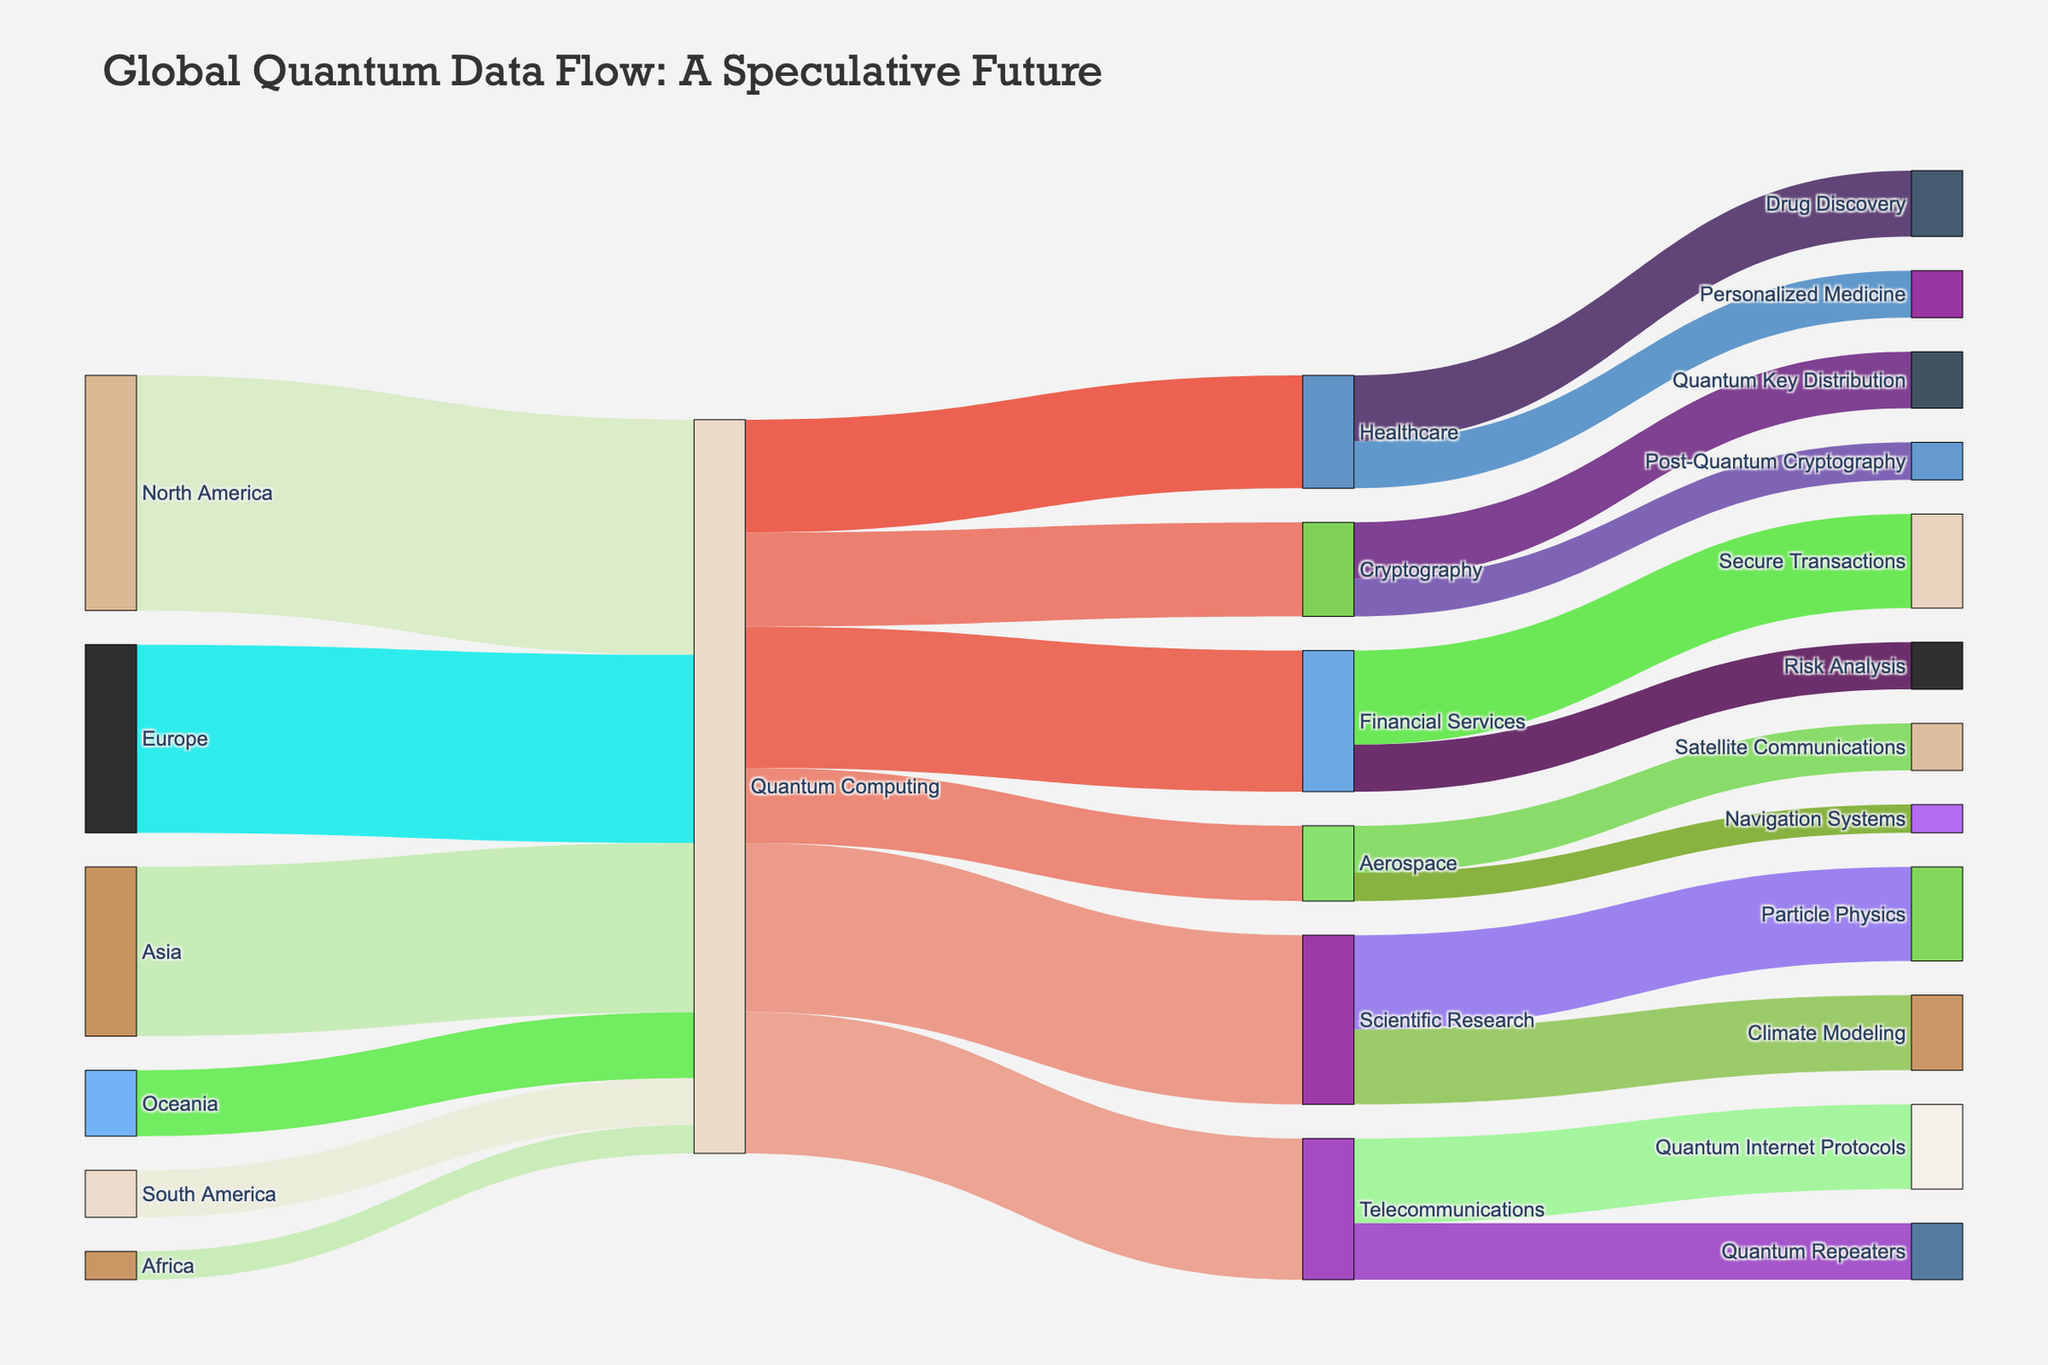What is the title of the figure? The title of the figure is usually displayed at the top in a larger font.
Answer: Global Quantum Data Flow: A Speculative Future Which continent contributes the highest number of quantum bits to Quantum Computing? By analyzing the thickness of the links connected to Quantum Computing from different continents, it's evident that North America has the thickest link, indicating it contributes the most quantum bits.
Answer: North America How many quantum bits are allocated to Financial Services from Quantum Computing? By looking at the link connecting Quantum Computing to Financial Services, you can see the value next to it.
Answer: 150 What is the total number of quantum bits utilized in Healthcare and Financial Services combined? Adding the values for Healthcare (120) and Financial Services (150) from Quantum Computing gives us the total.
Answer: 270 From which three continents does Quantum Computing receive the smallest contribution of quantum bits? Finding the three smallest values in the links connecting the continents to Quantum Computing: Africa (30), South America (50), and Oceania (70).
Answer: Africa, South America, Oceania Which application under Telecommunications receives the most quantum bits? Within the Telecommunications category, the link Quantum Internet Protocols has a higher value than Quantum Repeaters.
Answer: Quantum Internet Protocols Compare the quantum bits used in Cryptography and Scientific Research. Which receives more? Comparing values, Cryptography has 100 quantum bits while Scientific Research has 180 quantum bits.
Answer: Scientific Research What is the total number of quantum bits starting from Quantum Computing and ending in Secure Transactions? First, identify the quantum bits to Financial Services (150), and within Financial Services, the part going to Secure Transactions is 100.
Answer: 100 How many quantum bits are distributed between Aerospace and Telecommunications? Summing the quantum bits for Aerospace (80) and Telecommunications (150) from Quantum Computing.
Answer: 230 Which specific sub-application in Scientific Research gets the most quantum bits and how many? Within Scientific Research, the sub-application Particle Physics has more quantum bits (100) compared to Climate Modeling (80).
Answer: Particle Physics, 100 